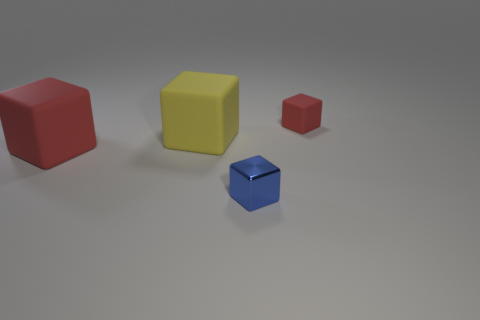Subtract all green blocks. Subtract all gray spheres. How many blocks are left? 4 Add 2 purple rubber cubes. How many objects exist? 6 Add 1 cubes. How many cubes exist? 5 Subtract 0 brown spheres. How many objects are left? 4 Subtract all blue cylinders. Subtract all yellow rubber blocks. How many objects are left? 3 Add 2 tiny blue things. How many tiny blue things are left? 3 